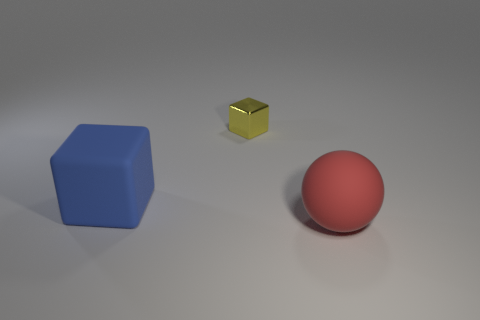Add 2 small cyan metal spheres. How many objects exist? 5 Subtract all blocks. How many objects are left? 1 Add 2 matte objects. How many matte objects exist? 4 Subtract 0 gray blocks. How many objects are left? 3 Subtract all tiny gray metallic blocks. Subtract all blue objects. How many objects are left? 2 Add 3 yellow metallic blocks. How many yellow metallic blocks are left? 4 